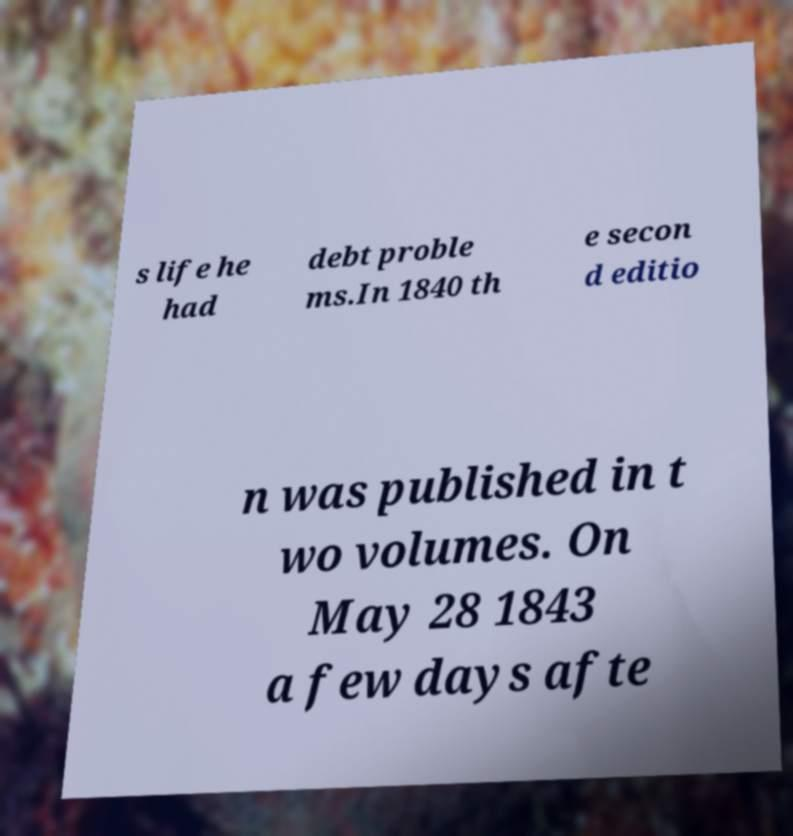Can you accurately transcribe the text from the provided image for me? s life he had debt proble ms.In 1840 th e secon d editio n was published in t wo volumes. On May 28 1843 a few days afte 